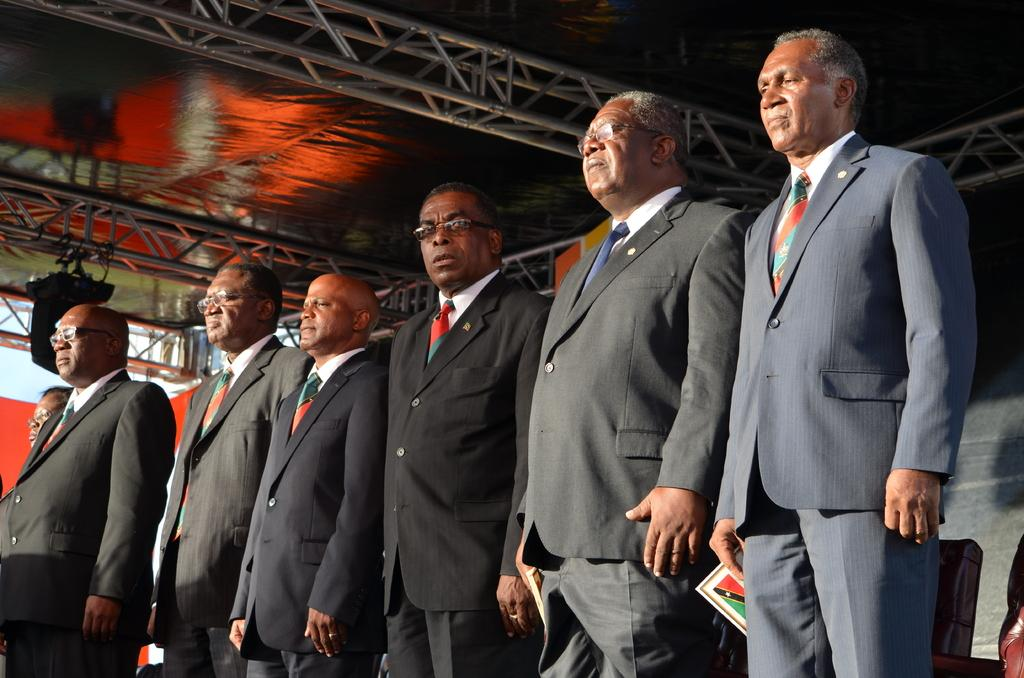What are the men in the image doing? There are men standing in the image, and two of them are holding books. What objects are the men holding? The two men are holding books. What can be seen in the background of the image? There are rods and an electrical device visible in the background of the image. What type of seed is being planted by the men in the image? There is no seed or planting activity depicted in the image; the men are holding books. 